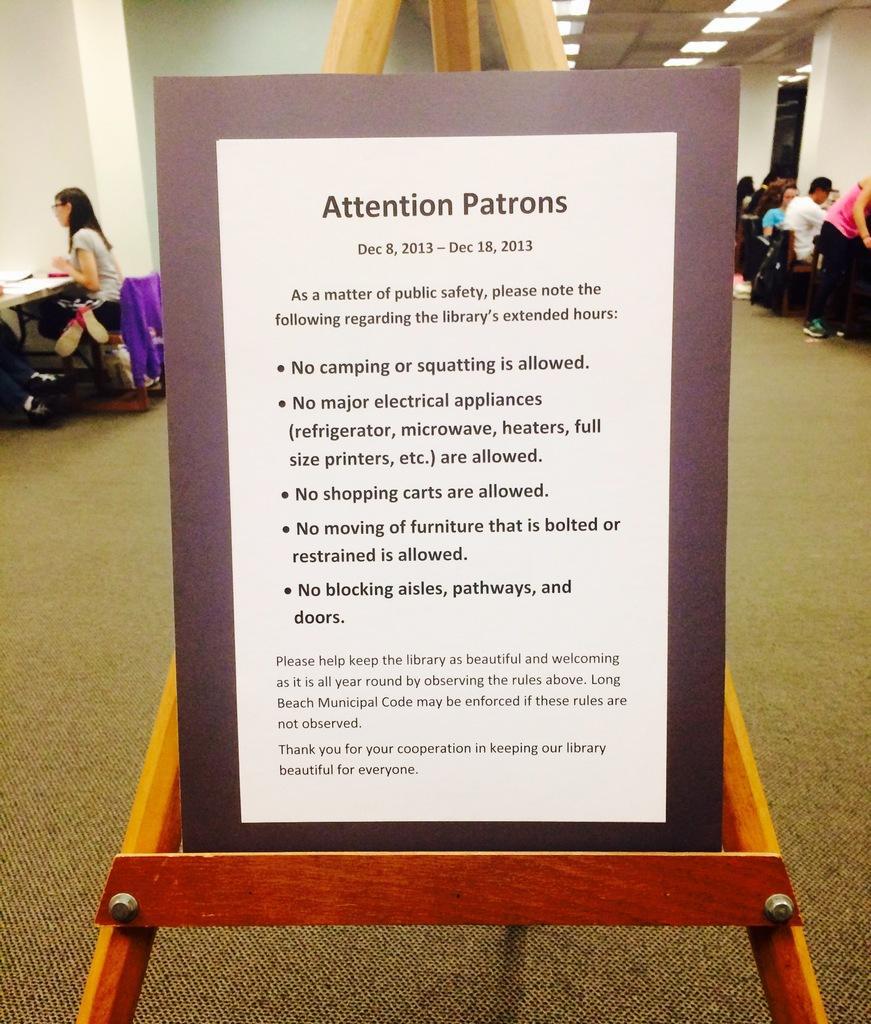Describe this image in one or two sentences. In this image I can see board and something is written on it. Back I can see few people are sitting on the chair. We can see some objects on the table. The wall is in white color. 